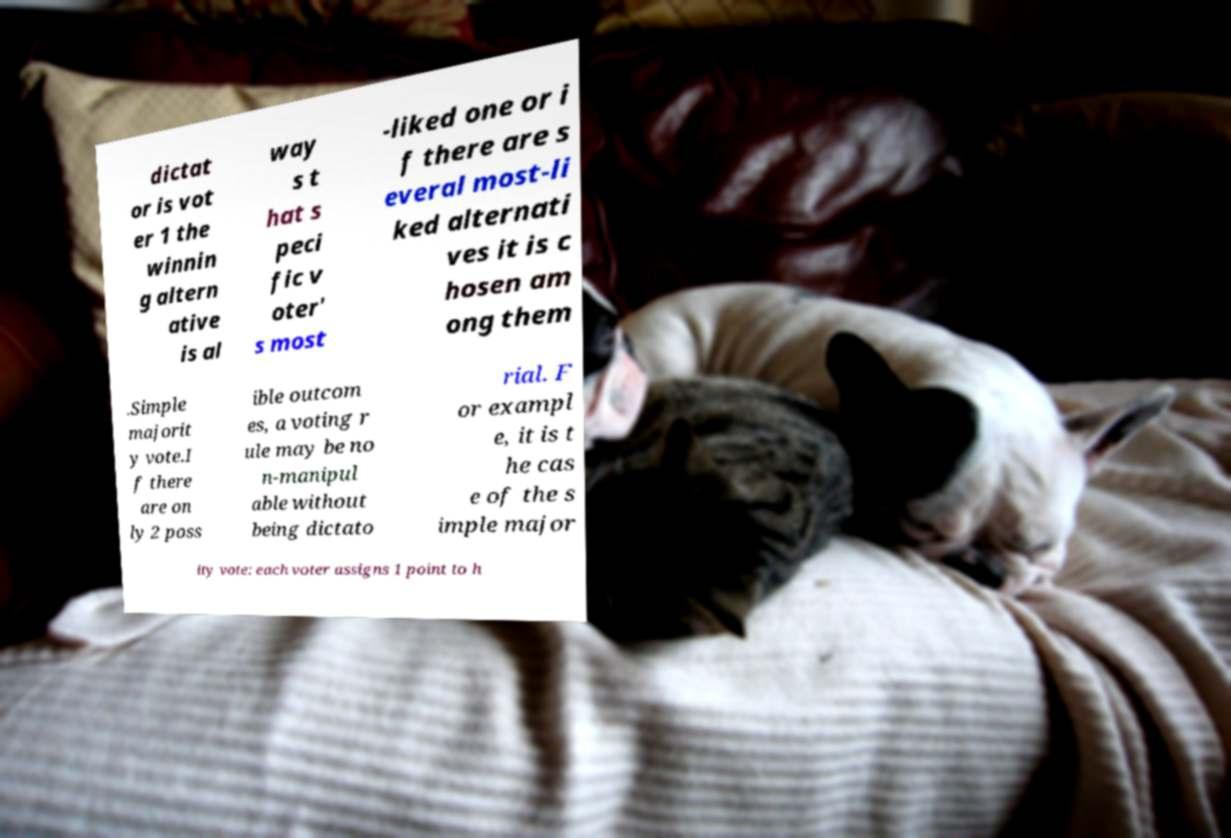Could you assist in decoding the text presented in this image and type it out clearly? dictat or is vot er 1 the winnin g altern ative is al way s t hat s peci fic v oter' s most -liked one or i f there are s everal most-li ked alternati ves it is c hosen am ong them .Simple majorit y vote.I f there are on ly 2 poss ible outcom es, a voting r ule may be no n-manipul able without being dictato rial. F or exampl e, it is t he cas e of the s imple major ity vote: each voter assigns 1 point to h 